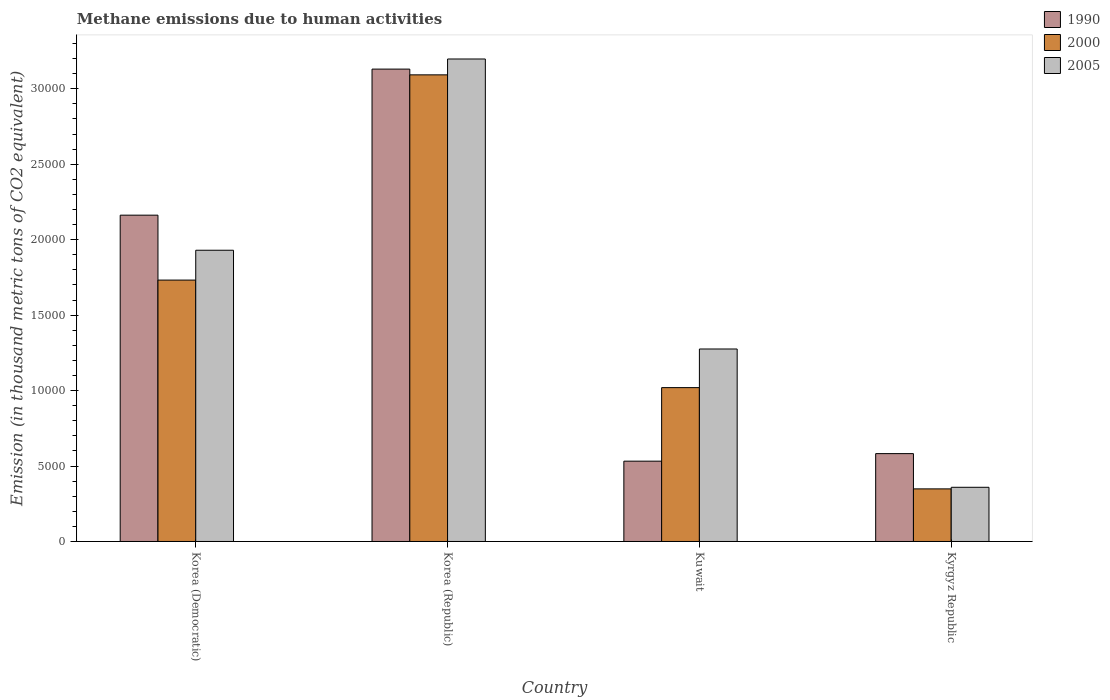Are the number of bars per tick equal to the number of legend labels?
Keep it short and to the point. Yes. What is the label of the 1st group of bars from the left?
Offer a terse response. Korea (Democratic). What is the amount of methane emitted in 2005 in Kuwait?
Make the answer very short. 1.28e+04. Across all countries, what is the maximum amount of methane emitted in 2005?
Give a very brief answer. 3.20e+04. Across all countries, what is the minimum amount of methane emitted in 2000?
Offer a terse response. 3485.8. In which country was the amount of methane emitted in 2000 maximum?
Your answer should be compact. Korea (Republic). In which country was the amount of methane emitted in 1990 minimum?
Provide a succinct answer. Kuwait. What is the total amount of methane emitted in 2000 in the graph?
Your answer should be very brief. 6.19e+04. What is the difference between the amount of methane emitted in 2005 in Korea (Republic) and that in Kuwait?
Provide a succinct answer. 1.92e+04. What is the difference between the amount of methane emitted in 2000 in Kuwait and the amount of methane emitted in 1990 in Korea (Democratic)?
Give a very brief answer. -1.14e+04. What is the average amount of methane emitted in 2005 per country?
Your response must be concise. 1.69e+04. What is the difference between the amount of methane emitted of/in 2000 and amount of methane emitted of/in 1990 in Korea (Democratic)?
Keep it short and to the point. -4301.8. What is the ratio of the amount of methane emitted in 1990 in Korea (Republic) to that in Kuwait?
Provide a succinct answer. 5.88. What is the difference between the highest and the second highest amount of methane emitted in 2000?
Provide a short and direct response. -7127.1. What is the difference between the highest and the lowest amount of methane emitted in 1990?
Make the answer very short. 2.60e+04. Is the sum of the amount of methane emitted in 2000 in Korea (Republic) and Kuwait greater than the maximum amount of methane emitted in 1990 across all countries?
Provide a short and direct response. Yes. What does the 2nd bar from the left in Kuwait represents?
Offer a very short reply. 2000. Is it the case that in every country, the sum of the amount of methane emitted in 2005 and amount of methane emitted in 1990 is greater than the amount of methane emitted in 2000?
Make the answer very short. Yes. Are all the bars in the graph horizontal?
Give a very brief answer. No. How many countries are there in the graph?
Keep it short and to the point. 4. Does the graph contain any zero values?
Provide a succinct answer. No. Does the graph contain grids?
Make the answer very short. No. Where does the legend appear in the graph?
Give a very brief answer. Top right. How many legend labels are there?
Ensure brevity in your answer.  3. What is the title of the graph?
Make the answer very short. Methane emissions due to human activities. What is the label or title of the X-axis?
Ensure brevity in your answer.  Country. What is the label or title of the Y-axis?
Your answer should be very brief. Emission (in thousand metric tons of CO2 equivalent). What is the Emission (in thousand metric tons of CO2 equivalent) of 1990 in Korea (Democratic)?
Make the answer very short. 2.16e+04. What is the Emission (in thousand metric tons of CO2 equivalent) in 2000 in Korea (Democratic)?
Ensure brevity in your answer.  1.73e+04. What is the Emission (in thousand metric tons of CO2 equivalent) of 2005 in Korea (Democratic)?
Provide a short and direct response. 1.93e+04. What is the Emission (in thousand metric tons of CO2 equivalent) of 1990 in Korea (Republic)?
Keep it short and to the point. 3.13e+04. What is the Emission (in thousand metric tons of CO2 equivalent) in 2000 in Korea (Republic)?
Your answer should be compact. 3.09e+04. What is the Emission (in thousand metric tons of CO2 equivalent) of 2005 in Korea (Republic)?
Provide a succinct answer. 3.20e+04. What is the Emission (in thousand metric tons of CO2 equivalent) in 1990 in Kuwait?
Make the answer very short. 5323.1. What is the Emission (in thousand metric tons of CO2 equivalent) in 2000 in Kuwait?
Keep it short and to the point. 1.02e+04. What is the Emission (in thousand metric tons of CO2 equivalent) of 2005 in Kuwait?
Offer a very short reply. 1.28e+04. What is the Emission (in thousand metric tons of CO2 equivalent) of 1990 in Kyrgyz Republic?
Make the answer very short. 5822.6. What is the Emission (in thousand metric tons of CO2 equivalent) of 2000 in Kyrgyz Republic?
Your answer should be very brief. 3485.8. What is the Emission (in thousand metric tons of CO2 equivalent) in 2005 in Kyrgyz Republic?
Your answer should be compact. 3591.3. Across all countries, what is the maximum Emission (in thousand metric tons of CO2 equivalent) of 1990?
Offer a terse response. 3.13e+04. Across all countries, what is the maximum Emission (in thousand metric tons of CO2 equivalent) in 2000?
Give a very brief answer. 3.09e+04. Across all countries, what is the maximum Emission (in thousand metric tons of CO2 equivalent) of 2005?
Your answer should be very brief. 3.20e+04. Across all countries, what is the minimum Emission (in thousand metric tons of CO2 equivalent) in 1990?
Provide a succinct answer. 5323.1. Across all countries, what is the minimum Emission (in thousand metric tons of CO2 equivalent) in 2000?
Your answer should be very brief. 3485.8. Across all countries, what is the minimum Emission (in thousand metric tons of CO2 equivalent) of 2005?
Provide a succinct answer. 3591.3. What is the total Emission (in thousand metric tons of CO2 equivalent) in 1990 in the graph?
Your answer should be compact. 6.41e+04. What is the total Emission (in thousand metric tons of CO2 equivalent) of 2000 in the graph?
Your response must be concise. 6.19e+04. What is the total Emission (in thousand metric tons of CO2 equivalent) of 2005 in the graph?
Offer a terse response. 6.76e+04. What is the difference between the Emission (in thousand metric tons of CO2 equivalent) of 1990 in Korea (Democratic) and that in Korea (Republic)?
Offer a very short reply. -9680.3. What is the difference between the Emission (in thousand metric tons of CO2 equivalent) of 2000 in Korea (Democratic) and that in Korea (Republic)?
Provide a short and direct response. -1.36e+04. What is the difference between the Emission (in thousand metric tons of CO2 equivalent) in 2005 in Korea (Democratic) and that in Korea (Republic)?
Provide a short and direct response. -1.27e+04. What is the difference between the Emission (in thousand metric tons of CO2 equivalent) of 1990 in Korea (Democratic) and that in Kuwait?
Ensure brevity in your answer.  1.63e+04. What is the difference between the Emission (in thousand metric tons of CO2 equivalent) in 2000 in Korea (Democratic) and that in Kuwait?
Your answer should be compact. 7127.1. What is the difference between the Emission (in thousand metric tons of CO2 equivalent) of 2005 in Korea (Democratic) and that in Kuwait?
Give a very brief answer. 6544.1. What is the difference between the Emission (in thousand metric tons of CO2 equivalent) in 1990 in Korea (Democratic) and that in Kyrgyz Republic?
Keep it short and to the point. 1.58e+04. What is the difference between the Emission (in thousand metric tons of CO2 equivalent) of 2000 in Korea (Democratic) and that in Kyrgyz Republic?
Ensure brevity in your answer.  1.38e+04. What is the difference between the Emission (in thousand metric tons of CO2 equivalent) in 2005 in Korea (Democratic) and that in Kyrgyz Republic?
Provide a succinct answer. 1.57e+04. What is the difference between the Emission (in thousand metric tons of CO2 equivalent) of 1990 in Korea (Republic) and that in Kuwait?
Your answer should be compact. 2.60e+04. What is the difference between the Emission (in thousand metric tons of CO2 equivalent) of 2000 in Korea (Republic) and that in Kuwait?
Your response must be concise. 2.07e+04. What is the difference between the Emission (in thousand metric tons of CO2 equivalent) of 2005 in Korea (Republic) and that in Kuwait?
Offer a very short reply. 1.92e+04. What is the difference between the Emission (in thousand metric tons of CO2 equivalent) of 1990 in Korea (Republic) and that in Kyrgyz Republic?
Give a very brief answer. 2.55e+04. What is the difference between the Emission (in thousand metric tons of CO2 equivalent) in 2000 in Korea (Republic) and that in Kyrgyz Republic?
Offer a terse response. 2.74e+04. What is the difference between the Emission (in thousand metric tons of CO2 equivalent) in 2005 in Korea (Republic) and that in Kyrgyz Republic?
Make the answer very short. 2.84e+04. What is the difference between the Emission (in thousand metric tons of CO2 equivalent) of 1990 in Kuwait and that in Kyrgyz Republic?
Provide a short and direct response. -499.5. What is the difference between the Emission (in thousand metric tons of CO2 equivalent) of 2000 in Kuwait and that in Kyrgyz Republic?
Provide a short and direct response. 6711. What is the difference between the Emission (in thousand metric tons of CO2 equivalent) of 2005 in Kuwait and that in Kyrgyz Republic?
Offer a terse response. 9165.5. What is the difference between the Emission (in thousand metric tons of CO2 equivalent) of 1990 in Korea (Democratic) and the Emission (in thousand metric tons of CO2 equivalent) of 2000 in Korea (Republic)?
Make the answer very short. -9299.2. What is the difference between the Emission (in thousand metric tons of CO2 equivalent) of 1990 in Korea (Democratic) and the Emission (in thousand metric tons of CO2 equivalent) of 2005 in Korea (Republic)?
Offer a terse response. -1.04e+04. What is the difference between the Emission (in thousand metric tons of CO2 equivalent) in 2000 in Korea (Democratic) and the Emission (in thousand metric tons of CO2 equivalent) in 2005 in Korea (Republic)?
Make the answer very short. -1.47e+04. What is the difference between the Emission (in thousand metric tons of CO2 equivalent) of 1990 in Korea (Democratic) and the Emission (in thousand metric tons of CO2 equivalent) of 2000 in Kuwait?
Provide a short and direct response. 1.14e+04. What is the difference between the Emission (in thousand metric tons of CO2 equivalent) in 1990 in Korea (Democratic) and the Emission (in thousand metric tons of CO2 equivalent) in 2005 in Kuwait?
Your response must be concise. 8868.9. What is the difference between the Emission (in thousand metric tons of CO2 equivalent) in 2000 in Korea (Democratic) and the Emission (in thousand metric tons of CO2 equivalent) in 2005 in Kuwait?
Your answer should be compact. 4567.1. What is the difference between the Emission (in thousand metric tons of CO2 equivalent) in 1990 in Korea (Democratic) and the Emission (in thousand metric tons of CO2 equivalent) in 2000 in Kyrgyz Republic?
Give a very brief answer. 1.81e+04. What is the difference between the Emission (in thousand metric tons of CO2 equivalent) of 1990 in Korea (Democratic) and the Emission (in thousand metric tons of CO2 equivalent) of 2005 in Kyrgyz Republic?
Keep it short and to the point. 1.80e+04. What is the difference between the Emission (in thousand metric tons of CO2 equivalent) of 2000 in Korea (Democratic) and the Emission (in thousand metric tons of CO2 equivalent) of 2005 in Kyrgyz Republic?
Give a very brief answer. 1.37e+04. What is the difference between the Emission (in thousand metric tons of CO2 equivalent) in 1990 in Korea (Republic) and the Emission (in thousand metric tons of CO2 equivalent) in 2000 in Kuwait?
Make the answer very short. 2.11e+04. What is the difference between the Emission (in thousand metric tons of CO2 equivalent) in 1990 in Korea (Republic) and the Emission (in thousand metric tons of CO2 equivalent) in 2005 in Kuwait?
Provide a short and direct response. 1.85e+04. What is the difference between the Emission (in thousand metric tons of CO2 equivalent) in 2000 in Korea (Republic) and the Emission (in thousand metric tons of CO2 equivalent) in 2005 in Kuwait?
Give a very brief answer. 1.82e+04. What is the difference between the Emission (in thousand metric tons of CO2 equivalent) in 1990 in Korea (Republic) and the Emission (in thousand metric tons of CO2 equivalent) in 2000 in Kyrgyz Republic?
Provide a short and direct response. 2.78e+04. What is the difference between the Emission (in thousand metric tons of CO2 equivalent) in 1990 in Korea (Republic) and the Emission (in thousand metric tons of CO2 equivalent) in 2005 in Kyrgyz Republic?
Your answer should be very brief. 2.77e+04. What is the difference between the Emission (in thousand metric tons of CO2 equivalent) of 2000 in Korea (Republic) and the Emission (in thousand metric tons of CO2 equivalent) of 2005 in Kyrgyz Republic?
Keep it short and to the point. 2.73e+04. What is the difference between the Emission (in thousand metric tons of CO2 equivalent) of 1990 in Kuwait and the Emission (in thousand metric tons of CO2 equivalent) of 2000 in Kyrgyz Republic?
Offer a very short reply. 1837.3. What is the difference between the Emission (in thousand metric tons of CO2 equivalent) of 1990 in Kuwait and the Emission (in thousand metric tons of CO2 equivalent) of 2005 in Kyrgyz Republic?
Keep it short and to the point. 1731.8. What is the difference between the Emission (in thousand metric tons of CO2 equivalent) in 2000 in Kuwait and the Emission (in thousand metric tons of CO2 equivalent) in 2005 in Kyrgyz Republic?
Give a very brief answer. 6605.5. What is the average Emission (in thousand metric tons of CO2 equivalent) in 1990 per country?
Provide a succinct answer. 1.60e+04. What is the average Emission (in thousand metric tons of CO2 equivalent) of 2000 per country?
Your answer should be compact. 1.55e+04. What is the average Emission (in thousand metric tons of CO2 equivalent) of 2005 per country?
Offer a very short reply. 1.69e+04. What is the difference between the Emission (in thousand metric tons of CO2 equivalent) of 1990 and Emission (in thousand metric tons of CO2 equivalent) of 2000 in Korea (Democratic)?
Give a very brief answer. 4301.8. What is the difference between the Emission (in thousand metric tons of CO2 equivalent) in 1990 and Emission (in thousand metric tons of CO2 equivalent) in 2005 in Korea (Democratic)?
Offer a very short reply. 2324.8. What is the difference between the Emission (in thousand metric tons of CO2 equivalent) in 2000 and Emission (in thousand metric tons of CO2 equivalent) in 2005 in Korea (Democratic)?
Your answer should be very brief. -1977. What is the difference between the Emission (in thousand metric tons of CO2 equivalent) of 1990 and Emission (in thousand metric tons of CO2 equivalent) of 2000 in Korea (Republic)?
Your response must be concise. 381.1. What is the difference between the Emission (in thousand metric tons of CO2 equivalent) of 1990 and Emission (in thousand metric tons of CO2 equivalent) of 2005 in Korea (Republic)?
Your answer should be very brief. -669.8. What is the difference between the Emission (in thousand metric tons of CO2 equivalent) of 2000 and Emission (in thousand metric tons of CO2 equivalent) of 2005 in Korea (Republic)?
Offer a terse response. -1050.9. What is the difference between the Emission (in thousand metric tons of CO2 equivalent) of 1990 and Emission (in thousand metric tons of CO2 equivalent) of 2000 in Kuwait?
Ensure brevity in your answer.  -4873.7. What is the difference between the Emission (in thousand metric tons of CO2 equivalent) of 1990 and Emission (in thousand metric tons of CO2 equivalent) of 2005 in Kuwait?
Provide a succinct answer. -7433.7. What is the difference between the Emission (in thousand metric tons of CO2 equivalent) in 2000 and Emission (in thousand metric tons of CO2 equivalent) in 2005 in Kuwait?
Your answer should be compact. -2560. What is the difference between the Emission (in thousand metric tons of CO2 equivalent) in 1990 and Emission (in thousand metric tons of CO2 equivalent) in 2000 in Kyrgyz Republic?
Keep it short and to the point. 2336.8. What is the difference between the Emission (in thousand metric tons of CO2 equivalent) of 1990 and Emission (in thousand metric tons of CO2 equivalent) of 2005 in Kyrgyz Republic?
Provide a short and direct response. 2231.3. What is the difference between the Emission (in thousand metric tons of CO2 equivalent) in 2000 and Emission (in thousand metric tons of CO2 equivalent) in 2005 in Kyrgyz Republic?
Keep it short and to the point. -105.5. What is the ratio of the Emission (in thousand metric tons of CO2 equivalent) in 1990 in Korea (Democratic) to that in Korea (Republic)?
Your response must be concise. 0.69. What is the ratio of the Emission (in thousand metric tons of CO2 equivalent) in 2000 in Korea (Democratic) to that in Korea (Republic)?
Offer a terse response. 0.56. What is the ratio of the Emission (in thousand metric tons of CO2 equivalent) of 2005 in Korea (Democratic) to that in Korea (Republic)?
Ensure brevity in your answer.  0.6. What is the ratio of the Emission (in thousand metric tons of CO2 equivalent) in 1990 in Korea (Democratic) to that in Kuwait?
Keep it short and to the point. 4.06. What is the ratio of the Emission (in thousand metric tons of CO2 equivalent) of 2000 in Korea (Democratic) to that in Kuwait?
Give a very brief answer. 1.7. What is the ratio of the Emission (in thousand metric tons of CO2 equivalent) of 2005 in Korea (Democratic) to that in Kuwait?
Your answer should be very brief. 1.51. What is the ratio of the Emission (in thousand metric tons of CO2 equivalent) of 1990 in Korea (Democratic) to that in Kyrgyz Republic?
Provide a succinct answer. 3.71. What is the ratio of the Emission (in thousand metric tons of CO2 equivalent) in 2000 in Korea (Democratic) to that in Kyrgyz Republic?
Ensure brevity in your answer.  4.97. What is the ratio of the Emission (in thousand metric tons of CO2 equivalent) of 2005 in Korea (Democratic) to that in Kyrgyz Republic?
Your response must be concise. 5.37. What is the ratio of the Emission (in thousand metric tons of CO2 equivalent) of 1990 in Korea (Republic) to that in Kuwait?
Provide a succinct answer. 5.88. What is the ratio of the Emission (in thousand metric tons of CO2 equivalent) in 2000 in Korea (Republic) to that in Kuwait?
Make the answer very short. 3.03. What is the ratio of the Emission (in thousand metric tons of CO2 equivalent) in 2005 in Korea (Republic) to that in Kuwait?
Provide a succinct answer. 2.51. What is the ratio of the Emission (in thousand metric tons of CO2 equivalent) in 1990 in Korea (Republic) to that in Kyrgyz Republic?
Your answer should be very brief. 5.38. What is the ratio of the Emission (in thousand metric tons of CO2 equivalent) of 2000 in Korea (Republic) to that in Kyrgyz Republic?
Offer a very short reply. 8.87. What is the ratio of the Emission (in thousand metric tons of CO2 equivalent) of 2005 in Korea (Republic) to that in Kyrgyz Republic?
Make the answer very short. 8.9. What is the ratio of the Emission (in thousand metric tons of CO2 equivalent) in 1990 in Kuwait to that in Kyrgyz Republic?
Provide a succinct answer. 0.91. What is the ratio of the Emission (in thousand metric tons of CO2 equivalent) in 2000 in Kuwait to that in Kyrgyz Republic?
Provide a short and direct response. 2.93. What is the ratio of the Emission (in thousand metric tons of CO2 equivalent) in 2005 in Kuwait to that in Kyrgyz Republic?
Make the answer very short. 3.55. What is the difference between the highest and the second highest Emission (in thousand metric tons of CO2 equivalent) in 1990?
Your answer should be very brief. 9680.3. What is the difference between the highest and the second highest Emission (in thousand metric tons of CO2 equivalent) of 2000?
Your response must be concise. 1.36e+04. What is the difference between the highest and the second highest Emission (in thousand metric tons of CO2 equivalent) in 2005?
Ensure brevity in your answer.  1.27e+04. What is the difference between the highest and the lowest Emission (in thousand metric tons of CO2 equivalent) in 1990?
Keep it short and to the point. 2.60e+04. What is the difference between the highest and the lowest Emission (in thousand metric tons of CO2 equivalent) in 2000?
Provide a succinct answer. 2.74e+04. What is the difference between the highest and the lowest Emission (in thousand metric tons of CO2 equivalent) in 2005?
Offer a terse response. 2.84e+04. 